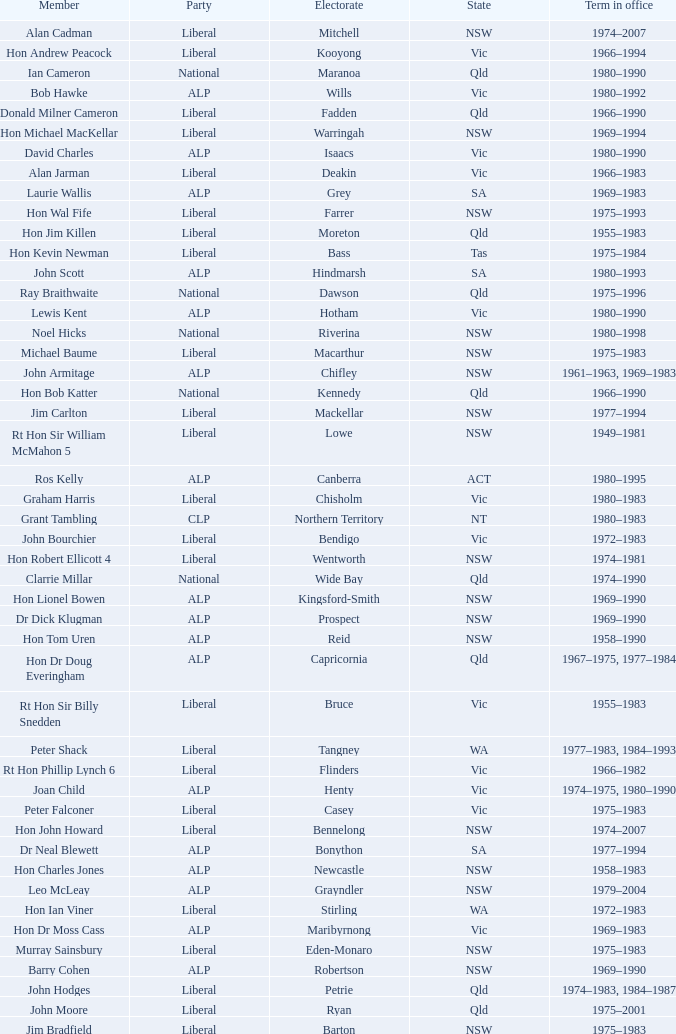What party is Mick Young a member of? ALP. 